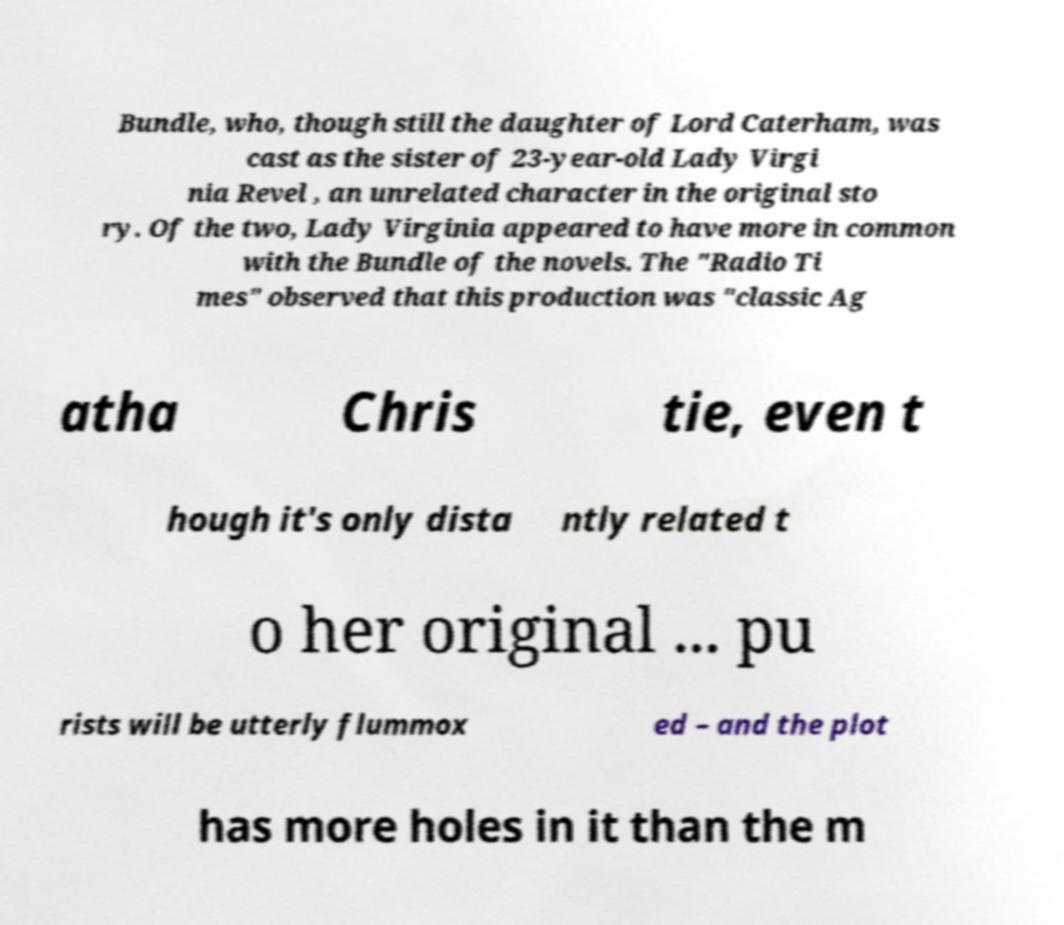Can you read and provide the text displayed in the image?This photo seems to have some interesting text. Can you extract and type it out for me? Bundle, who, though still the daughter of Lord Caterham, was cast as the sister of 23-year-old Lady Virgi nia Revel , an unrelated character in the original sto ry. Of the two, Lady Virginia appeared to have more in common with the Bundle of the novels. The "Radio Ti mes" observed that this production was "classic Ag atha Chris tie, even t hough it's only dista ntly related t o her original ... pu rists will be utterly flummox ed – and the plot has more holes in it than the m 